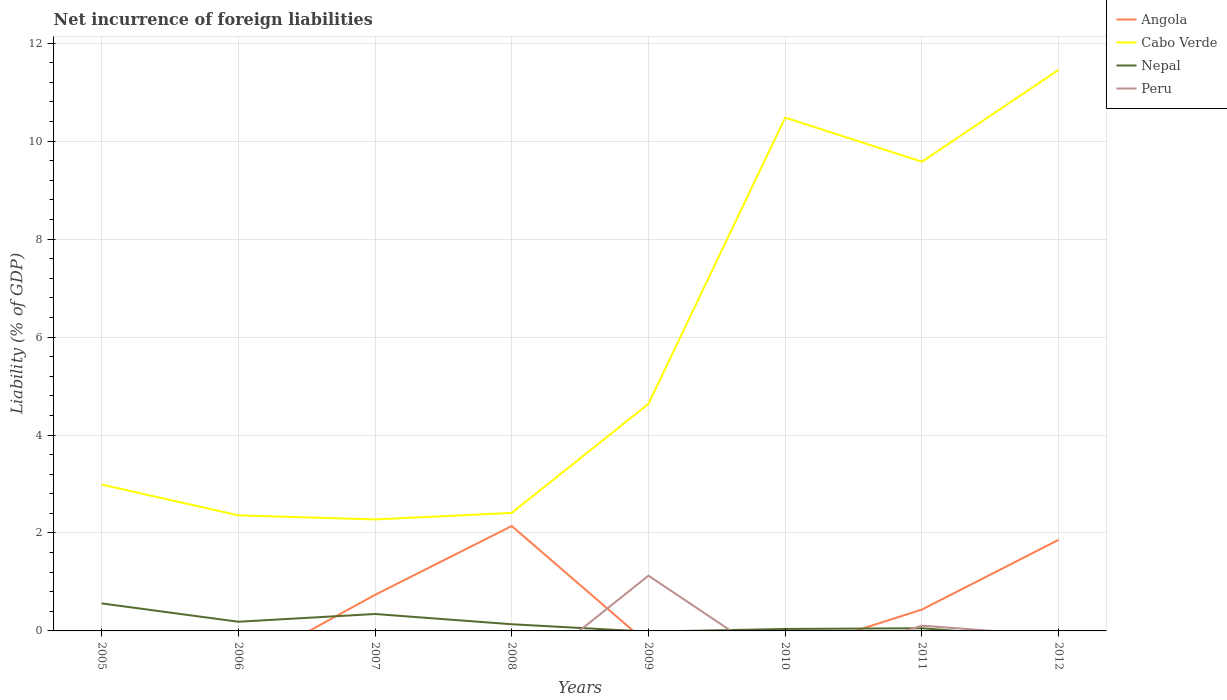Across all years, what is the maximum net incurrence of foreign liabilities in Cabo Verde?
Offer a terse response. 2.28. What is the total net incurrence of foreign liabilities in Nepal in the graph?
Your response must be concise. 0.21. What is the difference between the highest and the second highest net incurrence of foreign liabilities in Nepal?
Provide a succinct answer. 0.56. How many lines are there?
Offer a terse response. 4. How many years are there in the graph?
Offer a terse response. 8. What is the difference between two consecutive major ticks on the Y-axis?
Your answer should be very brief. 2. Are the values on the major ticks of Y-axis written in scientific E-notation?
Offer a terse response. No. Does the graph contain any zero values?
Your answer should be very brief. Yes. How many legend labels are there?
Provide a succinct answer. 4. How are the legend labels stacked?
Offer a very short reply. Vertical. What is the title of the graph?
Offer a very short reply. Net incurrence of foreign liabilities. What is the label or title of the X-axis?
Ensure brevity in your answer.  Years. What is the label or title of the Y-axis?
Provide a succinct answer. Liability (% of GDP). What is the Liability (% of GDP) of Angola in 2005?
Keep it short and to the point. 0. What is the Liability (% of GDP) of Cabo Verde in 2005?
Ensure brevity in your answer.  2.99. What is the Liability (% of GDP) in Nepal in 2005?
Offer a terse response. 0.56. What is the Liability (% of GDP) in Angola in 2006?
Provide a succinct answer. 0. What is the Liability (% of GDP) of Cabo Verde in 2006?
Provide a short and direct response. 2.36. What is the Liability (% of GDP) of Nepal in 2006?
Your response must be concise. 0.19. What is the Liability (% of GDP) of Angola in 2007?
Your answer should be very brief. 0.74. What is the Liability (% of GDP) of Cabo Verde in 2007?
Provide a succinct answer. 2.28. What is the Liability (% of GDP) of Nepal in 2007?
Keep it short and to the point. 0.35. What is the Liability (% of GDP) in Peru in 2007?
Make the answer very short. 0. What is the Liability (% of GDP) of Angola in 2008?
Provide a short and direct response. 2.14. What is the Liability (% of GDP) of Cabo Verde in 2008?
Provide a succinct answer. 2.41. What is the Liability (% of GDP) of Nepal in 2008?
Make the answer very short. 0.14. What is the Liability (% of GDP) in Peru in 2008?
Offer a terse response. 0. What is the Liability (% of GDP) in Cabo Verde in 2009?
Give a very brief answer. 4.64. What is the Liability (% of GDP) of Peru in 2009?
Give a very brief answer. 1.13. What is the Liability (% of GDP) in Angola in 2010?
Provide a succinct answer. 0. What is the Liability (% of GDP) in Cabo Verde in 2010?
Offer a very short reply. 10.48. What is the Liability (% of GDP) in Nepal in 2010?
Offer a very short reply. 0.04. What is the Liability (% of GDP) in Angola in 2011?
Make the answer very short. 0.44. What is the Liability (% of GDP) in Cabo Verde in 2011?
Keep it short and to the point. 9.58. What is the Liability (% of GDP) of Nepal in 2011?
Offer a very short reply. 0.05. What is the Liability (% of GDP) of Peru in 2011?
Your answer should be compact. 0.11. What is the Liability (% of GDP) in Angola in 2012?
Your response must be concise. 1.86. What is the Liability (% of GDP) in Cabo Verde in 2012?
Keep it short and to the point. 11.46. What is the Liability (% of GDP) of Nepal in 2012?
Your response must be concise. 0. Across all years, what is the maximum Liability (% of GDP) in Angola?
Your answer should be compact. 2.14. Across all years, what is the maximum Liability (% of GDP) in Cabo Verde?
Provide a succinct answer. 11.46. Across all years, what is the maximum Liability (% of GDP) of Nepal?
Keep it short and to the point. 0.56. Across all years, what is the maximum Liability (% of GDP) of Peru?
Offer a very short reply. 1.13. Across all years, what is the minimum Liability (% of GDP) of Angola?
Keep it short and to the point. 0. Across all years, what is the minimum Liability (% of GDP) of Cabo Verde?
Ensure brevity in your answer.  2.28. Across all years, what is the minimum Liability (% of GDP) of Nepal?
Your answer should be very brief. 0. What is the total Liability (% of GDP) of Angola in the graph?
Keep it short and to the point. 5.17. What is the total Liability (% of GDP) of Cabo Verde in the graph?
Keep it short and to the point. 46.19. What is the total Liability (% of GDP) in Nepal in the graph?
Your answer should be very brief. 1.33. What is the total Liability (% of GDP) in Peru in the graph?
Make the answer very short. 1.24. What is the difference between the Liability (% of GDP) in Cabo Verde in 2005 and that in 2006?
Provide a succinct answer. 0.63. What is the difference between the Liability (% of GDP) in Nepal in 2005 and that in 2006?
Make the answer very short. 0.37. What is the difference between the Liability (% of GDP) of Cabo Verde in 2005 and that in 2007?
Offer a very short reply. 0.71. What is the difference between the Liability (% of GDP) of Nepal in 2005 and that in 2007?
Give a very brief answer. 0.22. What is the difference between the Liability (% of GDP) of Cabo Verde in 2005 and that in 2008?
Your response must be concise. 0.58. What is the difference between the Liability (% of GDP) of Nepal in 2005 and that in 2008?
Make the answer very short. 0.43. What is the difference between the Liability (% of GDP) in Cabo Verde in 2005 and that in 2009?
Make the answer very short. -1.65. What is the difference between the Liability (% of GDP) of Cabo Verde in 2005 and that in 2010?
Offer a terse response. -7.49. What is the difference between the Liability (% of GDP) in Nepal in 2005 and that in 2010?
Provide a short and direct response. 0.52. What is the difference between the Liability (% of GDP) in Cabo Verde in 2005 and that in 2011?
Provide a succinct answer. -6.59. What is the difference between the Liability (% of GDP) in Nepal in 2005 and that in 2011?
Offer a very short reply. 0.51. What is the difference between the Liability (% of GDP) of Cabo Verde in 2005 and that in 2012?
Make the answer very short. -8.47. What is the difference between the Liability (% of GDP) of Cabo Verde in 2006 and that in 2007?
Ensure brevity in your answer.  0.08. What is the difference between the Liability (% of GDP) in Nepal in 2006 and that in 2007?
Provide a succinct answer. -0.16. What is the difference between the Liability (% of GDP) in Cabo Verde in 2006 and that in 2008?
Your response must be concise. -0.05. What is the difference between the Liability (% of GDP) of Nepal in 2006 and that in 2008?
Offer a terse response. 0.05. What is the difference between the Liability (% of GDP) in Cabo Verde in 2006 and that in 2009?
Offer a very short reply. -2.28. What is the difference between the Liability (% of GDP) in Cabo Verde in 2006 and that in 2010?
Your answer should be compact. -8.12. What is the difference between the Liability (% of GDP) in Nepal in 2006 and that in 2010?
Your answer should be compact. 0.15. What is the difference between the Liability (% of GDP) in Cabo Verde in 2006 and that in 2011?
Ensure brevity in your answer.  -7.22. What is the difference between the Liability (% of GDP) of Nepal in 2006 and that in 2011?
Your answer should be compact. 0.13. What is the difference between the Liability (% of GDP) of Cabo Verde in 2006 and that in 2012?
Ensure brevity in your answer.  -9.1. What is the difference between the Liability (% of GDP) in Angola in 2007 and that in 2008?
Provide a short and direct response. -1.41. What is the difference between the Liability (% of GDP) of Cabo Verde in 2007 and that in 2008?
Your answer should be compact. -0.13. What is the difference between the Liability (% of GDP) of Nepal in 2007 and that in 2008?
Your response must be concise. 0.21. What is the difference between the Liability (% of GDP) in Cabo Verde in 2007 and that in 2009?
Offer a terse response. -2.36. What is the difference between the Liability (% of GDP) of Cabo Verde in 2007 and that in 2010?
Ensure brevity in your answer.  -8.2. What is the difference between the Liability (% of GDP) in Nepal in 2007 and that in 2010?
Provide a succinct answer. 0.31. What is the difference between the Liability (% of GDP) in Angola in 2007 and that in 2011?
Your response must be concise. 0.3. What is the difference between the Liability (% of GDP) of Cabo Verde in 2007 and that in 2011?
Provide a short and direct response. -7.3. What is the difference between the Liability (% of GDP) in Nepal in 2007 and that in 2011?
Provide a succinct answer. 0.29. What is the difference between the Liability (% of GDP) of Angola in 2007 and that in 2012?
Give a very brief answer. -1.12. What is the difference between the Liability (% of GDP) of Cabo Verde in 2007 and that in 2012?
Provide a succinct answer. -9.18. What is the difference between the Liability (% of GDP) in Cabo Verde in 2008 and that in 2009?
Your answer should be compact. -2.23. What is the difference between the Liability (% of GDP) in Cabo Verde in 2008 and that in 2010?
Provide a short and direct response. -8.07. What is the difference between the Liability (% of GDP) in Nepal in 2008 and that in 2010?
Offer a very short reply. 0.1. What is the difference between the Liability (% of GDP) of Angola in 2008 and that in 2011?
Offer a very short reply. 1.71. What is the difference between the Liability (% of GDP) of Cabo Verde in 2008 and that in 2011?
Keep it short and to the point. -7.17. What is the difference between the Liability (% of GDP) in Nepal in 2008 and that in 2011?
Provide a short and direct response. 0.08. What is the difference between the Liability (% of GDP) of Angola in 2008 and that in 2012?
Make the answer very short. 0.28. What is the difference between the Liability (% of GDP) in Cabo Verde in 2008 and that in 2012?
Give a very brief answer. -9.05. What is the difference between the Liability (% of GDP) in Cabo Verde in 2009 and that in 2010?
Provide a short and direct response. -5.84. What is the difference between the Liability (% of GDP) in Cabo Verde in 2009 and that in 2011?
Offer a terse response. -4.94. What is the difference between the Liability (% of GDP) in Peru in 2009 and that in 2011?
Your answer should be compact. 1.02. What is the difference between the Liability (% of GDP) in Cabo Verde in 2009 and that in 2012?
Keep it short and to the point. -6.82. What is the difference between the Liability (% of GDP) of Cabo Verde in 2010 and that in 2011?
Make the answer very short. 0.9. What is the difference between the Liability (% of GDP) in Nepal in 2010 and that in 2011?
Your answer should be very brief. -0.01. What is the difference between the Liability (% of GDP) of Cabo Verde in 2010 and that in 2012?
Offer a terse response. -0.98. What is the difference between the Liability (% of GDP) in Angola in 2011 and that in 2012?
Keep it short and to the point. -1.42. What is the difference between the Liability (% of GDP) in Cabo Verde in 2011 and that in 2012?
Your answer should be very brief. -1.88. What is the difference between the Liability (% of GDP) of Cabo Verde in 2005 and the Liability (% of GDP) of Nepal in 2006?
Ensure brevity in your answer.  2.8. What is the difference between the Liability (% of GDP) in Cabo Verde in 2005 and the Liability (% of GDP) in Nepal in 2007?
Ensure brevity in your answer.  2.64. What is the difference between the Liability (% of GDP) in Cabo Verde in 2005 and the Liability (% of GDP) in Nepal in 2008?
Keep it short and to the point. 2.85. What is the difference between the Liability (% of GDP) of Cabo Verde in 2005 and the Liability (% of GDP) of Peru in 2009?
Make the answer very short. 1.86. What is the difference between the Liability (% of GDP) of Nepal in 2005 and the Liability (% of GDP) of Peru in 2009?
Ensure brevity in your answer.  -0.57. What is the difference between the Liability (% of GDP) in Cabo Verde in 2005 and the Liability (% of GDP) in Nepal in 2010?
Offer a very short reply. 2.95. What is the difference between the Liability (% of GDP) of Cabo Verde in 2005 and the Liability (% of GDP) of Nepal in 2011?
Provide a succinct answer. 2.93. What is the difference between the Liability (% of GDP) in Cabo Verde in 2005 and the Liability (% of GDP) in Peru in 2011?
Your answer should be compact. 2.88. What is the difference between the Liability (% of GDP) in Nepal in 2005 and the Liability (% of GDP) in Peru in 2011?
Give a very brief answer. 0.46. What is the difference between the Liability (% of GDP) in Cabo Verde in 2006 and the Liability (% of GDP) in Nepal in 2007?
Offer a terse response. 2.01. What is the difference between the Liability (% of GDP) of Cabo Verde in 2006 and the Liability (% of GDP) of Nepal in 2008?
Make the answer very short. 2.22. What is the difference between the Liability (% of GDP) of Cabo Verde in 2006 and the Liability (% of GDP) of Peru in 2009?
Keep it short and to the point. 1.23. What is the difference between the Liability (% of GDP) of Nepal in 2006 and the Liability (% of GDP) of Peru in 2009?
Offer a terse response. -0.94. What is the difference between the Liability (% of GDP) of Cabo Verde in 2006 and the Liability (% of GDP) of Nepal in 2010?
Your answer should be very brief. 2.32. What is the difference between the Liability (% of GDP) in Cabo Verde in 2006 and the Liability (% of GDP) in Nepal in 2011?
Keep it short and to the point. 2.3. What is the difference between the Liability (% of GDP) in Cabo Verde in 2006 and the Liability (% of GDP) in Peru in 2011?
Offer a very short reply. 2.25. What is the difference between the Liability (% of GDP) of Nepal in 2006 and the Liability (% of GDP) of Peru in 2011?
Give a very brief answer. 0.08. What is the difference between the Liability (% of GDP) of Angola in 2007 and the Liability (% of GDP) of Cabo Verde in 2008?
Provide a short and direct response. -1.67. What is the difference between the Liability (% of GDP) of Angola in 2007 and the Liability (% of GDP) of Nepal in 2008?
Offer a very short reply. 0.6. What is the difference between the Liability (% of GDP) of Cabo Verde in 2007 and the Liability (% of GDP) of Nepal in 2008?
Make the answer very short. 2.14. What is the difference between the Liability (% of GDP) in Angola in 2007 and the Liability (% of GDP) in Cabo Verde in 2009?
Give a very brief answer. -3.9. What is the difference between the Liability (% of GDP) in Angola in 2007 and the Liability (% of GDP) in Peru in 2009?
Provide a succinct answer. -0.39. What is the difference between the Liability (% of GDP) of Cabo Verde in 2007 and the Liability (% of GDP) of Peru in 2009?
Provide a short and direct response. 1.15. What is the difference between the Liability (% of GDP) of Nepal in 2007 and the Liability (% of GDP) of Peru in 2009?
Your answer should be compact. -0.78. What is the difference between the Liability (% of GDP) of Angola in 2007 and the Liability (% of GDP) of Cabo Verde in 2010?
Provide a short and direct response. -9.75. What is the difference between the Liability (% of GDP) of Angola in 2007 and the Liability (% of GDP) of Nepal in 2010?
Your response must be concise. 0.7. What is the difference between the Liability (% of GDP) of Cabo Verde in 2007 and the Liability (% of GDP) of Nepal in 2010?
Give a very brief answer. 2.24. What is the difference between the Liability (% of GDP) of Angola in 2007 and the Liability (% of GDP) of Cabo Verde in 2011?
Provide a short and direct response. -8.84. What is the difference between the Liability (% of GDP) of Angola in 2007 and the Liability (% of GDP) of Nepal in 2011?
Offer a terse response. 0.68. What is the difference between the Liability (% of GDP) of Angola in 2007 and the Liability (% of GDP) of Peru in 2011?
Provide a short and direct response. 0.63. What is the difference between the Liability (% of GDP) of Cabo Verde in 2007 and the Liability (% of GDP) of Nepal in 2011?
Your answer should be compact. 2.22. What is the difference between the Liability (% of GDP) of Cabo Verde in 2007 and the Liability (% of GDP) of Peru in 2011?
Make the answer very short. 2.17. What is the difference between the Liability (% of GDP) in Nepal in 2007 and the Liability (% of GDP) in Peru in 2011?
Offer a very short reply. 0.24. What is the difference between the Liability (% of GDP) of Angola in 2007 and the Liability (% of GDP) of Cabo Verde in 2012?
Make the answer very short. -10.72. What is the difference between the Liability (% of GDP) of Angola in 2008 and the Liability (% of GDP) of Cabo Verde in 2009?
Provide a short and direct response. -2.5. What is the difference between the Liability (% of GDP) in Angola in 2008 and the Liability (% of GDP) in Peru in 2009?
Your response must be concise. 1.01. What is the difference between the Liability (% of GDP) of Cabo Verde in 2008 and the Liability (% of GDP) of Peru in 2009?
Your response must be concise. 1.28. What is the difference between the Liability (% of GDP) in Nepal in 2008 and the Liability (% of GDP) in Peru in 2009?
Offer a very short reply. -0.99. What is the difference between the Liability (% of GDP) in Angola in 2008 and the Liability (% of GDP) in Cabo Verde in 2010?
Give a very brief answer. -8.34. What is the difference between the Liability (% of GDP) in Angola in 2008 and the Liability (% of GDP) in Nepal in 2010?
Your answer should be compact. 2.1. What is the difference between the Liability (% of GDP) in Cabo Verde in 2008 and the Liability (% of GDP) in Nepal in 2010?
Provide a succinct answer. 2.37. What is the difference between the Liability (% of GDP) in Angola in 2008 and the Liability (% of GDP) in Cabo Verde in 2011?
Provide a short and direct response. -7.44. What is the difference between the Liability (% of GDP) in Angola in 2008 and the Liability (% of GDP) in Nepal in 2011?
Offer a very short reply. 2.09. What is the difference between the Liability (% of GDP) in Angola in 2008 and the Liability (% of GDP) in Peru in 2011?
Your answer should be compact. 2.03. What is the difference between the Liability (% of GDP) in Cabo Verde in 2008 and the Liability (% of GDP) in Nepal in 2011?
Give a very brief answer. 2.35. What is the difference between the Liability (% of GDP) of Cabo Verde in 2008 and the Liability (% of GDP) of Peru in 2011?
Provide a succinct answer. 2.3. What is the difference between the Liability (% of GDP) of Nepal in 2008 and the Liability (% of GDP) of Peru in 2011?
Keep it short and to the point. 0.03. What is the difference between the Liability (% of GDP) of Angola in 2008 and the Liability (% of GDP) of Cabo Verde in 2012?
Offer a very short reply. -9.31. What is the difference between the Liability (% of GDP) of Cabo Verde in 2009 and the Liability (% of GDP) of Nepal in 2010?
Your answer should be compact. 4.6. What is the difference between the Liability (% of GDP) of Cabo Verde in 2009 and the Liability (% of GDP) of Nepal in 2011?
Give a very brief answer. 4.58. What is the difference between the Liability (% of GDP) in Cabo Verde in 2009 and the Liability (% of GDP) in Peru in 2011?
Offer a very short reply. 4.53. What is the difference between the Liability (% of GDP) of Cabo Verde in 2010 and the Liability (% of GDP) of Nepal in 2011?
Keep it short and to the point. 10.43. What is the difference between the Liability (% of GDP) in Cabo Verde in 2010 and the Liability (% of GDP) in Peru in 2011?
Your response must be concise. 10.37. What is the difference between the Liability (% of GDP) in Nepal in 2010 and the Liability (% of GDP) in Peru in 2011?
Offer a terse response. -0.07. What is the difference between the Liability (% of GDP) of Angola in 2011 and the Liability (% of GDP) of Cabo Verde in 2012?
Your answer should be very brief. -11.02. What is the average Liability (% of GDP) in Angola per year?
Provide a short and direct response. 0.65. What is the average Liability (% of GDP) in Cabo Verde per year?
Make the answer very short. 5.77. What is the average Liability (% of GDP) of Nepal per year?
Your answer should be compact. 0.17. What is the average Liability (% of GDP) in Peru per year?
Your response must be concise. 0.15. In the year 2005, what is the difference between the Liability (% of GDP) in Cabo Verde and Liability (% of GDP) in Nepal?
Provide a short and direct response. 2.43. In the year 2006, what is the difference between the Liability (% of GDP) of Cabo Verde and Liability (% of GDP) of Nepal?
Your response must be concise. 2.17. In the year 2007, what is the difference between the Liability (% of GDP) of Angola and Liability (% of GDP) of Cabo Verde?
Your answer should be very brief. -1.54. In the year 2007, what is the difference between the Liability (% of GDP) of Angola and Liability (% of GDP) of Nepal?
Provide a succinct answer. 0.39. In the year 2007, what is the difference between the Liability (% of GDP) of Cabo Verde and Liability (% of GDP) of Nepal?
Offer a very short reply. 1.93. In the year 2008, what is the difference between the Liability (% of GDP) in Angola and Liability (% of GDP) in Cabo Verde?
Your answer should be compact. -0.27. In the year 2008, what is the difference between the Liability (% of GDP) of Angola and Liability (% of GDP) of Nepal?
Ensure brevity in your answer.  2.01. In the year 2008, what is the difference between the Liability (% of GDP) of Cabo Verde and Liability (% of GDP) of Nepal?
Offer a very short reply. 2.27. In the year 2009, what is the difference between the Liability (% of GDP) in Cabo Verde and Liability (% of GDP) in Peru?
Provide a succinct answer. 3.51. In the year 2010, what is the difference between the Liability (% of GDP) in Cabo Verde and Liability (% of GDP) in Nepal?
Provide a short and direct response. 10.44. In the year 2011, what is the difference between the Liability (% of GDP) of Angola and Liability (% of GDP) of Cabo Verde?
Provide a short and direct response. -9.14. In the year 2011, what is the difference between the Liability (% of GDP) of Angola and Liability (% of GDP) of Nepal?
Keep it short and to the point. 0.38. In the year 2011, what is the difference between the Liability (% of GDP) of Angola and Liability (% of GDP) of Peru?
Offer a terse response. 0.33. In the year 2011, what is the difference between the Liability (% of GDP) in Cabo Verde and Liability (% of GDP) in Nepal?
Give a very brief answer. 9.53. In the year 2011, what is the difference between the Liability (% of GDP) in Cabo Verde and Liability (% of GDP) in Peru?
Give a very brief answer. 9.47. In the year 2011, what is the difference between the Liability (% of GDP) of Nepal and Liability (% of GDP) of Peru?
Your answer should be compact. -0.05. In the year 2012, what is the difference between the Liability (% of GDP) in Angola and Liability (% of GDP) in Cabo Verde?
Your answer should be compact. -9.6. What is the ratio of the Liability (% of GDP) of Cabo Verde in 2005 to that in 2006?
Offer a very short reply. 1.27. What is the ratio of the Liability (% of GDP) of Nepal in 2005 to that in 2006?
Your response must be concise. 3. What is the ratio of the Liability (% of GDP) in Cabo Verde in 2005 to that in 2007?
Give a very brief answer. 1.31. What is the ratio of the Liability (% of GDP) of Nepal in 2005 to that in 2007?
Ensure brevity in your answer.  1.63. What is the ratio of the Liability (% of GDP) in Cabo Verde in 2005 to that in 2008?
Make the answer very short. 1.24. What is the ratio of the Liability (% of GDP) in Nepal in 2005 to that in 2008?
Your answer should be compact. 4.13. What is the ratio of the Liability (% of GDP) in Cabo Verde in 2005 to that in 2009?
Provide a succinct answer. 0.64. What is the ratio of the Liability (% of GDP) in Cabo Verde in 2005 to that in 2010?
Keep it short and to the point. 0.29. What is the ratio of the Liability (% of GDP) of Nepal in 2005 to that in 2010?
Your response must be concise. 13.96. What is the ratio of the Liability (% of GDP) of Cabo Verde in 2005 to that in 2011?
Offer a terse response. 0.31. What is the ratio of the Liability (% of GDP) in Nepal in 2005 to that in 2011?
Provide a short and direct response. 10.25. What is the ratio of the Liability (% of GDP) of Cabo Verde in 2005 to that in 2012?
Offer a terse response. 0.26. What is the ratio of the Liability (% of GDP) of Cabo Verde in 2006 to that in 2007?
Provide a short and direct response. 1.04. What is the ratio of the Liability (% of GDP) of Nepal in 2006 to that in 2007?
Make the answer very short. 0.54. What is the ratio of the Liability (% of GDP) in Cabo Verde in 2006 to that in 2008?
Give a very brief answer. 0.98. What is the ratio of the Liability (% of GDP) of Nepal in 2006 to that in 2008?
Provide a succinct answer. 1.38. What is the ratio of the Liability (% of GDP) in Cabo Verde in 2006 to that in 2009?
Give a very brief answer. 0.51. What is the ratio of the Liability (% of GDP) of Cabo Verde in 2006 to that in 2010?
Your answer should be compact. 0.23. What is the ratio of the Liability (% of GDP) in Nepal in 2006 to that in 2010?
Provide a short and direct response. 4.66. What is the ratio of the Liability (% of GDP) of Cabo Verde in 2006 to that in 2011?
Provide a succinct answer. 0.25. What is the ratio of the Liability (% of GDP) in Nepal in 2006 to that in 2011?
Give a very brief answer. 3.42. What is the ratio of the Liability (% of GDP) of Cabo Verde in 2006 to that in 2012?
Provide a short and direct response. 0.21. What is the ratio of the Liability (% of GDP) of Angola in 2007 to that in 2008?
Give a very brief answer. 0.34. What is the ratio of the Liability (% of GDP) in Cabo Verde in 2007 to that in 2008?
Your answer should be compact. 0.94. What is the ratio of the Liability (% of GDP) of Nepal in 2007 to that in 2008?
Give a very brief answer. 2.54. What is the ratio of the Liability (% of GDP) in Cabo Verde in 2007 to that in 2009?
Provide a short and direct response. 0.49. What is the ratio of the Liability (% of GDP) in Cabo Verde in 2007 to that in 2010?
Provide a short and direct response. 0.22. What is the ratio of the Liability (% of GDP) in Nepal in 2007 to that in 2010?
Give a very brief answer. 8.58. What is the ratio of the Liability (% of GDP) in Angola in 2007 to that in 2011?
Ensure brevity in your answer.  1.69. What is the ratio of the Liability (% of GDP) of Cabo Verde in 2007 to that in 2011?
Your answer should be compact. 0.24. What is the ratio of the Liability (% of GDP) in Nepal in 2007 to that in 2011?
Your answer should be very brief. 6.3. What is the ratio of the Liability (% of GDP) of Angola in 2007 to that in 2012?
Keep it short and to the point. 0.4. What is the ratio of the Liability (% of GDP) in Cabo Verde in 2007 to that in 2012?
Offer a terse response. 0.2. What is the ratio of the Liability (% of GDP) of Cabo Verde in 2008 to that in 2009?
Keep it short and to the point. 0.52. What is the ratio of the Liability (% of GDP) in Cabo Verde in 2008 to that in 2010?
Give a very brief answer. 0.23. What is the ratio of the Liability (% of GDP) in Nepal in 2008 to that in 2010?
Provide a short and direct response. 3.38. What is the ratio of the Liability (% of GDP) of Angola in 2008 to that in 2011?
Give a very brief answer. 4.91. What is the ratio of the Liability (% of GDP) of Cabo Verde in 2008 to that in 2011?
Give a very brief answer. 0.25. What is the ratio of the Liability (% of GDP) of Nepal in 2008 to that in 2011?
Your answer should be very brief. 2.48. What is the ratio of the Liability (% of GDP) of Angola in 2008 to that in 2012?
Give a very brief answer. 1.15. What is the ratio of the Liability (% of GDP) of Cabo Verde in 2008 to that in 2012?
Your answer should be very brief. 0.21. What is the ratio of the Liability (% of GDP) of Cabo Verde in 2009 to that in 2010?
Keep it short and to the point. 0.44. What is the ratio of the Liability (% of GDP) of Cabo Verde in 2009 to that in 2011?
Keep it short and to the point. 0.48. What is the ratio of the Liability (% of GDP) in Peru in 2009 to that in 2011?
Your response must be concise. 10.54. What is the ratio of the Liability (% of GDP) of Cabo Verde in 2009 to that in 2012?
Your response must be concise. 0.4. What is the ratio of the Liability (% of GDP) of Cabo Verde in 2010 to that in 2011?
Give a very brief answer. 1.09. What is the ratio of the Liability (% of GDP) in Nepal in 2010 to that in 2011?
Offer a terse response. 0.73. What is the ratio of the Liability (% of GDP) of Cabo Verde in 2010 to that in 2012?
Offer a very short reply. 0.91. What is the ratio of the Liability (% of GDP) of Angola in 2011 to that in 2012?
Offer a terse response. 0.23. What is the ratio of the Liability (% of GDP) in Cabo Verde in 2011 to that in 2012?
Your answer should be compact. 0.84. What is the difference between the highest and the second highest Liability (% of GDP) in Angola?
Ensure brevity in your answer.  0.28. What is the difference between the highest and the second highest Liability (% of GDP) in Cabo Verde?
Ensure brevity in your answer.  0.98. What is the difference between the highest and the second highest Liability (% of GDP) in Nepal?
Make the answer very short. 0.22. What is the difference between the highest and the lowest Liability (% of GDP) of Angola?
Give a very brief answer. 2.14. What is the difference between the highest and the lowest Liability (% of GDP) of Cabo Verde?
Offer a very short reply. 9.18. What is the difference between the highest and the lowest Liability (% of GDP) of Nepal?
Provide a succinct answer. 0.56. What is the difference between the highest and the lowest Liability (% of GDP) of Peru?
Your response must be concise. 1.13. 